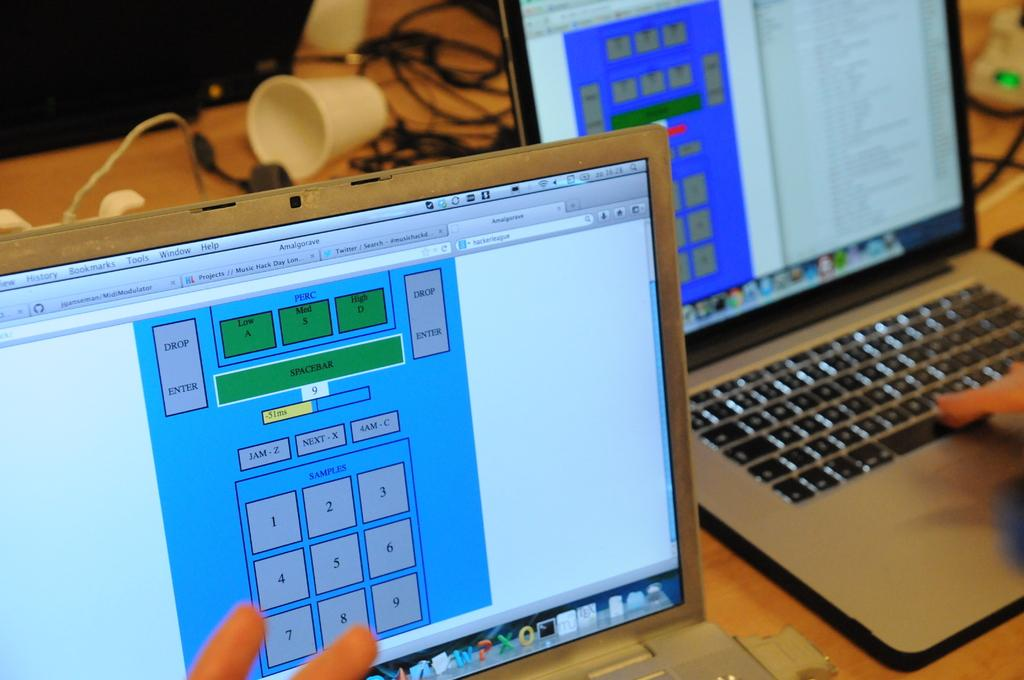Provide a one-sentence caption for the provided image. Two computer screens shown, the left screen has a top grey button saying drop enter. 